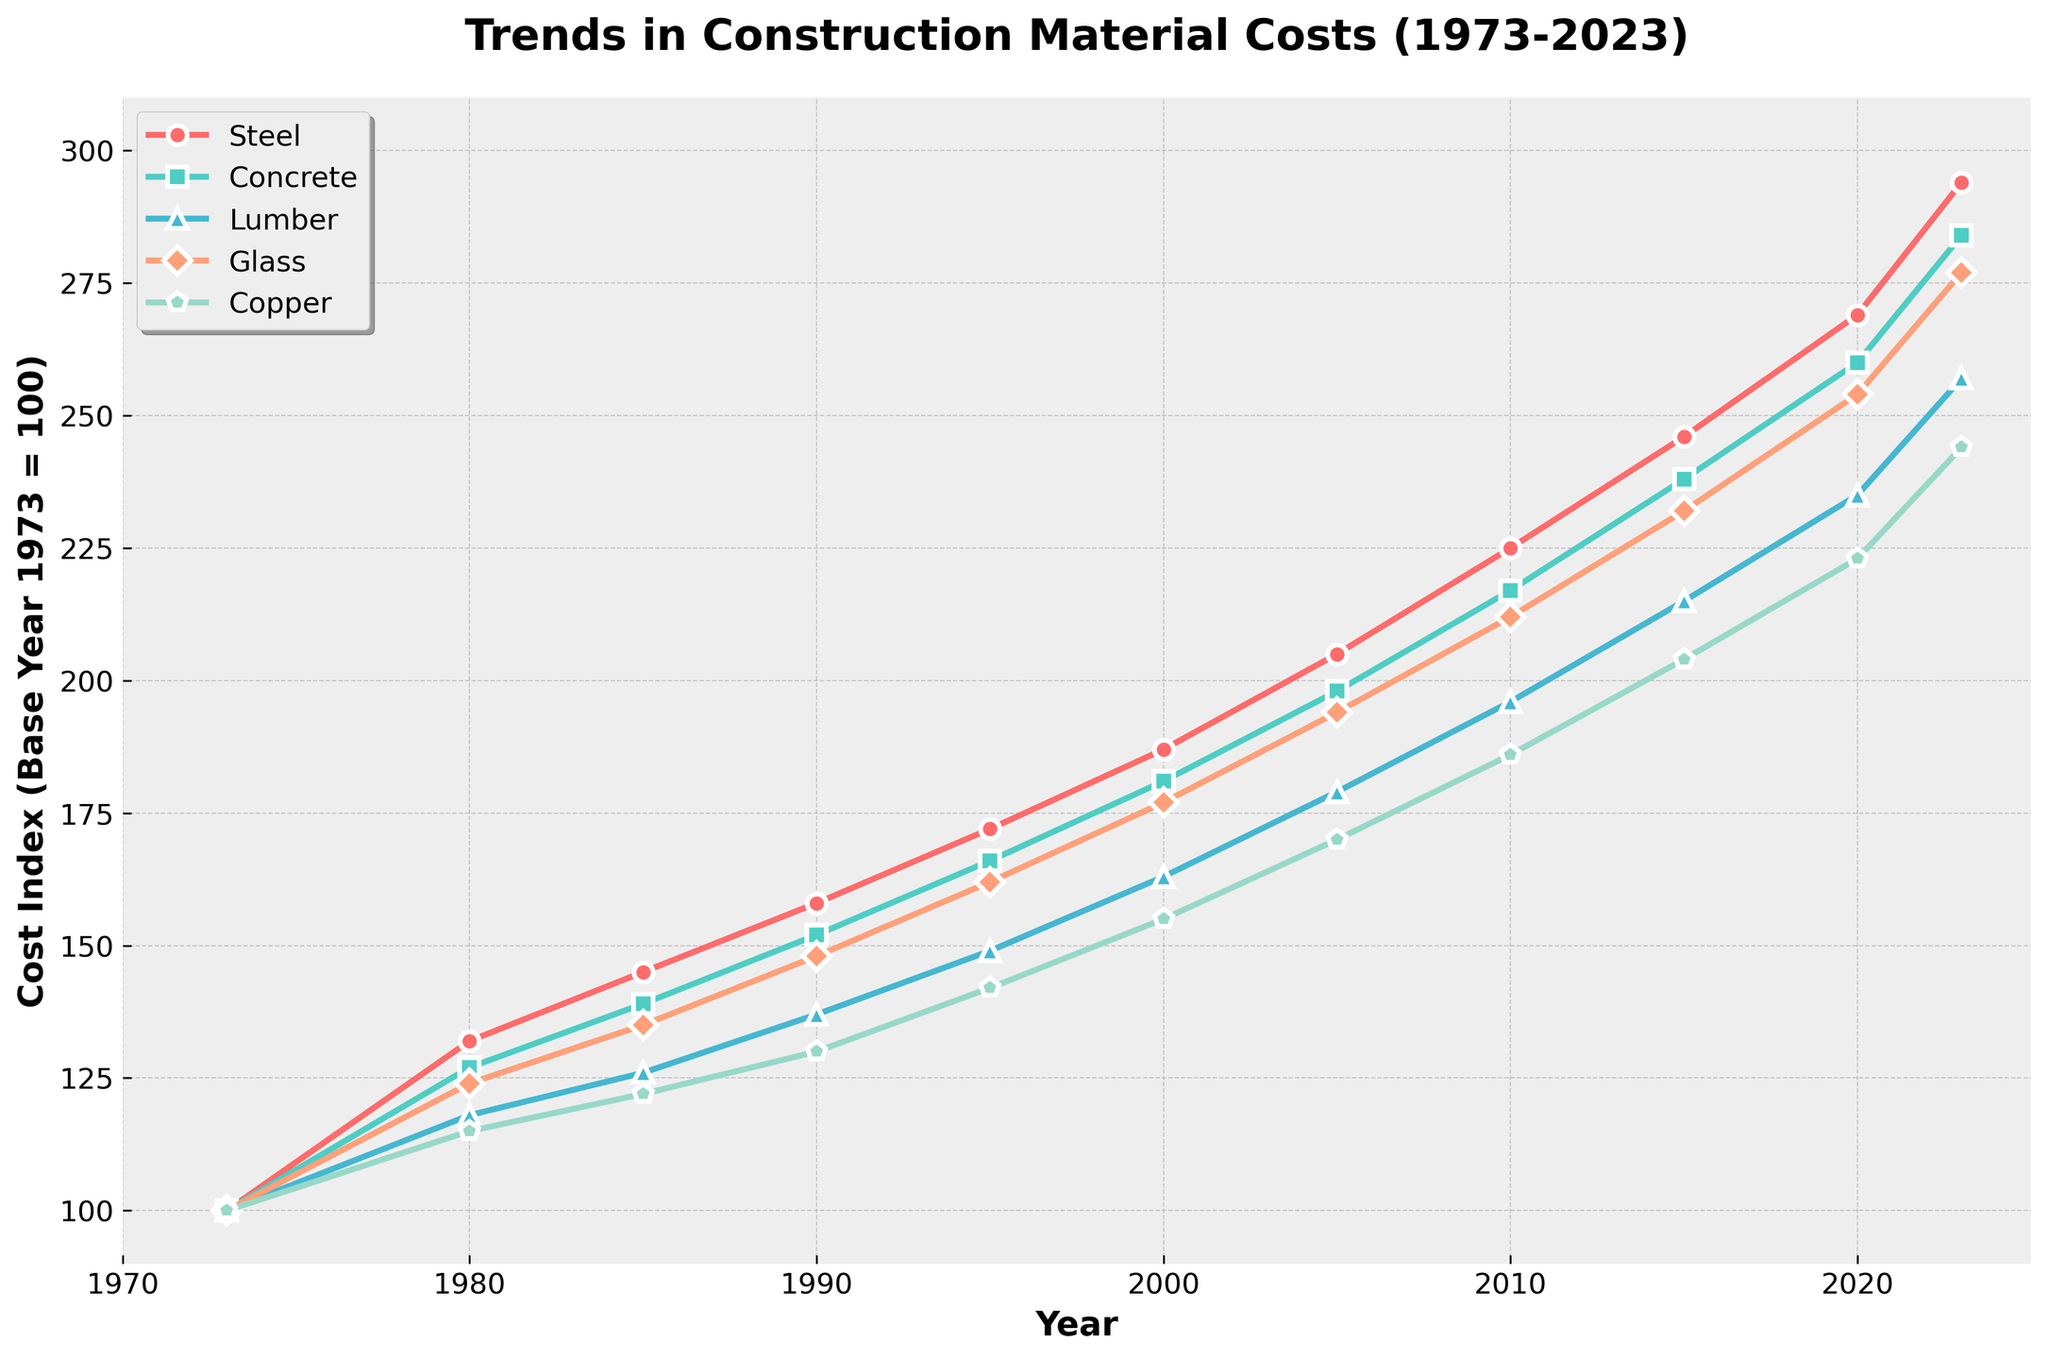Which construction material had the highest relative cost increase from 1973 to 2023? To find the material with the highest relative cost increase, compare the values from 1973 (base year) to 2023. Calculate the difference for each material: Steel (294-100=194), Concrete (284-100=184), Lumber (257-100=157), Glass (277-100=177), Copper (244-100=144). The highest increase is for Steel.
Answer: Steel How many years did it take for Concrete costs to roughly double since 1973? Check the 1973 cost index for Concrete, which is 100. Find when it approximately reaches 200, which occurs in 2005. Calculate the duration between 1973 and 2005 (2005-1973=32 years).
Answer: 32 years Between 1990 and 2010, which material shows the greatest increase in cost? Calculate the increase for each material between 1990 and 2010: Steel (225-158=67), Concrete (217-152=65), Lumber (196-137=59), Glass (212-148=64), Copper (186-130=56). The greatest increase is for Steel.
Answer: Steel Compare the cost indices of Lumber and Glass in 2020. Which one is higher and by how much? In 2020, the cost index for Lumber is 235 and for Glass is 254. Subtract the Lumber index from the Glass index to find the difference (254-235=19). Glass is higher by 19.
Answer: Glass by 19 Identify the two materials with the smallest growth difference from 1985 to 2000. Calculate the differences: Steel (187-145=42), Concrete (181-139=42), Lumber (163-126=37), Glass (177-135=42), Copper (155-122=33). The smallest growth differences are for Lumber (37) and Copper (33).
Answer: Lumber and Copper How does the growth of Copper costs compare with Glass costs between 1973 and 2023? Compute the index increase for Copper (244-100=144) and Glass (277-100=177). Then compare their growth (177 for Glass vs. 144 for Copper). Glass has a higher growth.
Answer: Glass has a higher growth Which material had a consistent increase every decade from 1973 to 2023 without any decline? Check each decade for consistent increase: Steel, Glass, and Concrete show consistent increases. Focus on one for exact confirmation – Steel increased consistently every decade.
Answer: Steel In 2000, how do the cost indices for Concrete and Copper compare to their respective indices in 1995? Calculate the increases: Concrete (181-166=15), Copper (155-142=13). Both materials increased from 1995 to 2000, with Concrete increasing by 15 and Copper by 13.
Answer: Concrete increased by 15, Copper increased by 13 